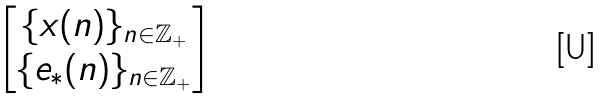<formula> <loc_0><loc_0><loc_500><loc_500>\begin{bmatrix} \{ x ( n ) \} _ { n \in { \mathbb { Z } } _ { + } } \\ \{ e _ { * } ( n ) \} _ { n \in { \mathbb { Z } } _ { + } } \end{bmatrix}</formula> 